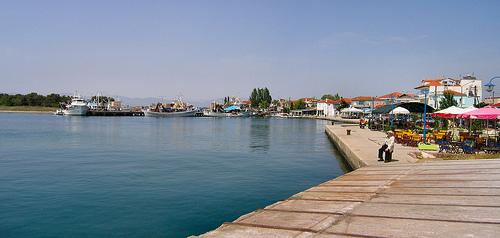Question: where is the man?
Choices:
A. Next to the water.
B. In the water.
C. Away from the water.
D. Under the water.
Answer with the letter. Answer: A Question: who is looking at the water?
Choices:
A. A man.
B. A woman.
C. A dog.
D. A cat.
Answer with the letter. Answer: A Question: how many men are there?
Choices:
A. Four.
B. Five.
C. One.
D. Six.
Answer with the letter. Answer: C Question: when was the photo taken?
Choices:
A. During the morning.
B. During the evening.
C. During the day.
D. During the night.
Answer with the letter. Answer: C Question: what color is the man's shirt?
Choices:
A. Black.
B. Purple.
C. White.
D. Blue.
Answer with the letter. Answer: C Question: what is the man doing?
Choices:
A. Standing.
B. Sitting.
C. Dancing.
D. Sleeping.
Answer with the letter. Answer: B 